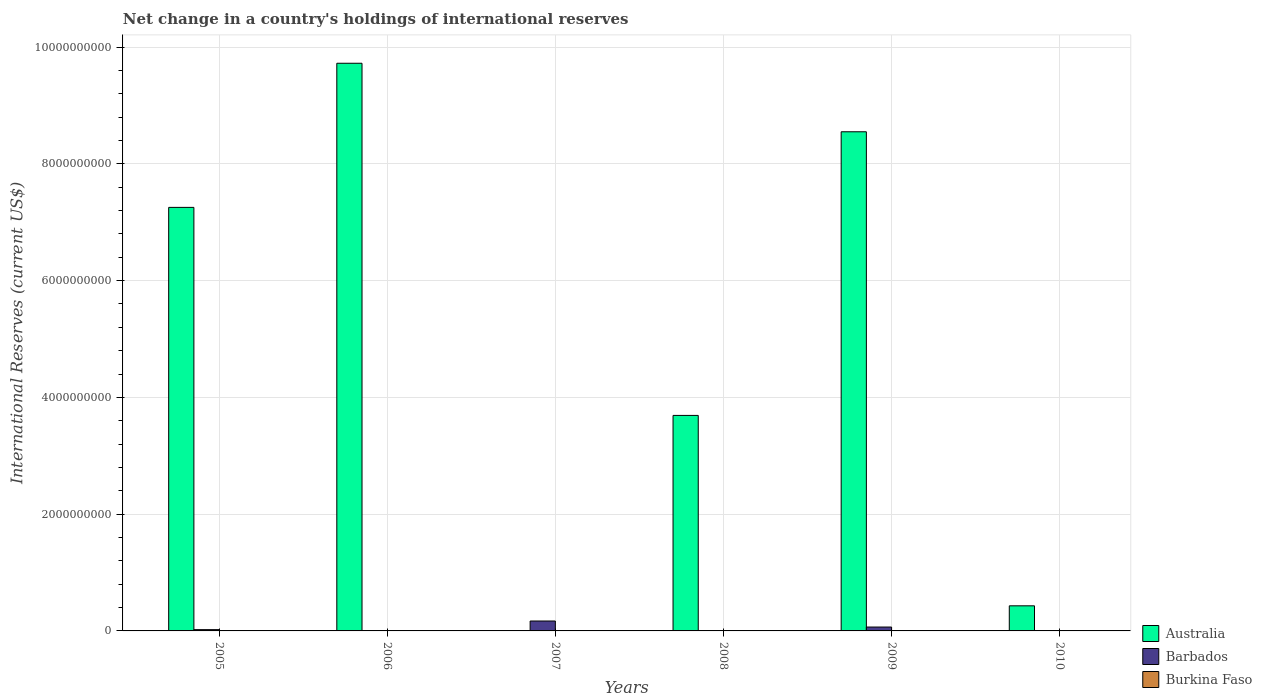How many different coloured bars are there?
Your answer should be compact. 2. Are the number of bars per tick equal to the number of legend labels?
Offer a terse response. No. What is the label of the 6th group of bars from the left?
Provide a short and direct response. 2010. In how many cases, is the number of bars for a given year not equal to the number of legend labels?
Your answer should be very brief. 6. What is the international reserves in Australia in 2007?
Provide a succinct answer. 0. Across all years, what is the maximum international reserves in Australia?
Make the answer very short. 9.72e+09. In which year was the international reserves in Barbados maximum?
Make the answer very short. 2007. What is the difference between the international reserves in Australia in 2006 and that in 2008?
Your answer should be very brief. 6.03e+09. What is the difference between the international reserves in Australia in 2008 and the international reserves in Barbados in 2006?
Ensure brevity in your answer.  3.69e+09. What is the average international reserves in Barbados per year?
Your answer should be compact. 4.30e+07. In the year 2009, what is the difference between the international reserves in Barbados and international reserves in Australia?
Your response must be concise. -8.48e+09. Is the international reserves in Australia in 2005 less than that in 2006?
Give a very brief answer. Yes. What is the difference between the highest and the second highest international reserves in Australia?
Make the answer very short. 1.17e+09. What is the difference between the highest and the lowest international reserves in Barbados?
Your answer should be very brief. 1.70e+08. In how many years, is the international reserves in Barbados greater than the average international reserves in Barbados taken over all years?
Provide a short and direct response. 2. Is the sum of the international reserves in Australia in 2005 and 2009 greater than the maximum international reserves in Barbados across all years?
Ensure brevity in your answer.  Yes. Is it the case that in every year, the sum of the international reserves in Burkina Faso and international reserves in Australia is greater than the international reserves in Barbados?
Ensure brevity in your answer.  No. How many bars are there?
Your answer should be very brief. 8. Are all the bars in the graph horizontal?
Keep it short and to the point. No. What is the difference between two consecutive major ticks on the Y-axis?
Your response must be concise. 2.00e+09. Are the values on the major ticks of Y-axis written in scientific E-notation?
Provide a succinct answer. No. Where does the legend appear in the graph?
Keep it short and to the point. Bottom right. How are the legend labels stacked?
Offer a very short reply. Vertical. What is the title of the graph?
Give a very brief answer. Net change in a country's holdings of international reserves. What is the label or title of the Y-axis?
Give a very brief answer. International Reserves (current US$). What is the International Reserves (current US$) of Australia in 2005?
Offer a terse response. 7.25e+09. What is the International Reserves (current US$) in Barbados in 2005?
Your answer should be compact. 2.19e+07. What is the International Reserves (current US$) in Burkina Faso in 2005?
Your answer should be compact. 0. What is the International Reserves (current US$) in Australia in 2006?
Offer a terse response. 9.72e+09. What is the International Reserves (current US$) in Barbados in 2006?
Provide a short and direct response. 0. What is the International Reserves (current US$) in Barbados in 2007?
Keep it short and to the point. 1.70e+08. What is the International Reserves (current US$) in Australia in 2008?
Give a very brief answer. 3.69e+09. What is the International Reserves (current US$) in Barbados in 2008?
Ensure brevity in your answer.  0. What is the International Reserves (current US$) in Burkina Faso in 2008?
Provide a short and direct response. 0. What is the International Reserves (current US$) in Australia in 2009?
Your answer should be compact. 8.55e+09. What is the International Reserves (current US$) in Barbados in 2009?
Make the answer very short. 6.65e+07. What is the International Reserves (current US$) of Burkina Faso in 2009?
Provide a succinct answer. 0. What is the International Reserves (current US$) in Australia in 2010?
Provide a succinct answer. 4.30e+08. What is the International Reserves (current US$) in Burkina Faso in 2010?
Keep it short and to the point. 0. Across all years, what is the maximum International Reserves (current US$) in Australia?
Keep it short and to the point. 9.72e+09. Across all years, what is the maximum International Reserves (current US$) of Barbados?
Your answer should be very brief. 1.70e+08. Across all years, what is the minimum International Reserves (current US$) in Australia?
Your answer should be very brief. 0. Across all years, what is the minimum International Reserves (current US$) of Barbados?
Your answer should be very brief. 0. What is the total International Reserves (current US$) of Australia in the graph?
Offer a very short reply. 2.96e+1. What is the total International Reserves (current US$) in Barbados in the graph?
Your answer should be very brief. 2.58e+08. What is the difference between the International Reserves (current US$) of Australia in 2005 and that in 2006?
Offer a very short reply. -2.47e+09. What is the difference between the International Reserves (current US$) in Barbados in 2005 and that in 2007?
Your answer should be compact. -1.48e+08. What is the difference between the International Reserves (current US$) in Australia in 2005 and that in 2008?
Your answer should be very brief. 3.56e+09. What is the difference between the International Reserves (current US$) of Australia in 2005 and that in 2009?
Give a very brief answer. -1.29e+09. What is the difference between the International Reserves (current US$) of Barbados in 2005 and that in 2009?
Make the answer very short. -4.46e+07. What is the difference between the International Reserves (current US$) of Australia in 2005 and that in 2010?
Provide a succinct answer. 6.82e+09. What is the difference between the International Reserves (current US$) of Australia in 2006 and that in 2008?
Your response must be concise. 6.03e+09. What is the difference between the International Reserves (current US$) in Australia in 2006 and that in 2009?
Offer a very short reply. 1.17e+09. What is the difference between the International Reserves (current US$) of Australia in 2006 and that in 2010?
Your answer should be compact. 9.29e+09. What is the difference between the International Reserves (current US$) in Barbados in 2007 and that in 2009?
Give a very brief answer. 1.03e+08. What is the difference between the International Reserves (current US$) of Australia in 2008 and that in 2009?
Provide a short and direct response. -4.86e+09. What is the difference between the International Reserves (current US$) of Australia in 2008 and that in 2010?
Give a very brief answer. 3.26e+09. What is the difference between the International Reserves (current US$) of Australia in 2009 and that in 2010?
Provide a short and direct response. 8.12e+09. What is the difference between the International Reserves (current US$) in Australia in 2005 and the International Reserves (current US$) in Barbados in 2007?
Your response must be concise. 7.08e+09. What is the difference between the International Reserves (current US$) in Australia in 2005 and the International Reserves (current US$) in Barbados in 2009?
Your answer should be very brief. 7.19e+09. What is the difference between the International Reserves (current US$) in Australia in 2006 and the International Reserves (current US$) in Barbados in 2007?
Ensure brevity in your answer.  9.55e+09. What is the difference between the International Reserves (current US$) of Australia in 2006 and the International Reserves (current US$) of Barbados in 2009?
Provide a short and direct response. 9.66e+09. What is the difference between the International Reserves (current US$) in Australia in 2008 and the International Reserves (current US$) in Barbados in 2009?
Give a very brief answer. 3.62e+09. What is the average International Reserves (current US$) of Australia per year?
Offer a very short reply. 4.94e+09. What is the average International Reserves (current US$) in Barbados per year?
Ensure brevity in your answer.  4.30e+07. In the year 2005, what is the difference between the International Reserves (current US$) of Australia and International Reserves (current US$) of Barbados?
Offer a terse response. 7.23e+09. In the year 2009, what is the difference between the International Reserves (current US$) in Australia and International Reserves (current US$) in Barbados?
Your answer should be compact. 8.48e+09. What is the ratio of the International Reserves (current US$) in Australia in 2005 to that in 2006?
Provide a succinct answer. 0.75. What is the ratio of the International Reserves (current US$) of Barbados in 2005 to that in 2007?
Provide a succinct answer. 0.13. What is the ratio of the International Reserves (current US$) in Australia in 2005 to that in 2008?
Keep it short and to the point. 1.97. What is the ratio of the International Reserves (current US$) in Australia in 2005 to that in 2009?
Keep it short and to the point. 0.85. What is the ratio of the International Reserves (current US$) of Barbados in 2005 to that in 2009?
Offer a terse response. 0.33. What is the ratio of the International Reserves (current US$) of Australia in 2005 to that in 2010?
Offer a very short reply. 16.87. What is the ratio of the International Reserves (current US$) in Australia in 2006 to that in 2008?
Keep it short and to the point. 2.63. What is the ratio of the International Reserves (current US$) in Australia in 2006 to that in 2009?
Provide a succinct answer. 1.14. What is the ratio of the International Reserves (current US$) in Australia in 2006 to that in 2010?
Your answer should be compact. 22.61. What is the ratio of the International Reserves (current US$) in Barbados in 2007 to that in 2009?
Your response must be concise. 2.55. What is the ratio of the International Reserves (current US$) of Australia in 2008 to that in 2009?
Your response must be concise. 0.43. What is the ratio of the International Reserves (current US$) in Australia in 2008 to that in 2010?
Provide a succinct answer. 8.59. What is the ratio of the International Reserves (current US$) of Australia in 2009 to that in 2010?
Provide a short and direct response. 19.88. What is the difference between the highest and the second highest International Reserves (current US$) of Australia?
Provide a succinct answer. 1.17e+09. What is the difference between the highest and the second highest International Reserves (current US$) of Barbados?
Give a very brief answer. 1.03e+08. What is the difference between the highest and the lowest International Reserves (current US$) in Australia?
Provide a succinct answer. 9.72e+09. What is the difference between the highest and the lowest International Reserves (current US$) of Barbados?
Ensure brevity in your answer.  1.70e+08. 